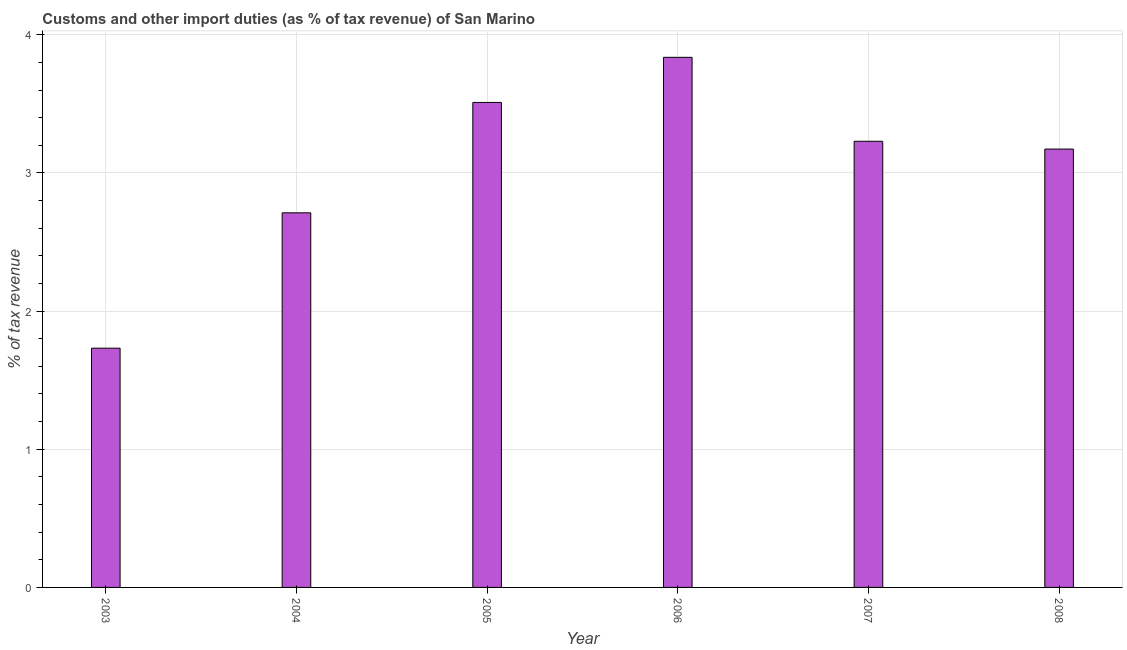Does the graph contain any zero values?
Provide a short and direct response. No. Does the graph contain grids?
Provide a short and direct response. Yes. What is the title of the graph?
Ensure brevity in your answer.  Customs and other import duties (as % of tax revenue) of San Marino. What is the label or title of the X-axis?
Provide a short and direct response. Year. What is the label or title of the Y-axis?
Give a very brief answer. % of tax revenue. What is the customs and other import duties in 2005?
Provide a succinct answer. 3.51. Across all years, what is the maximum customs and other import duties?
Your response must be concise. 3.84. Across all years, what is the minimum customs and other import duties?
Make the answer very short. 1.73. In which year was the customs and other import duties minimum?
Offer a terse response. 2003. What is the sum of the customs and other import duties?
Offer a very short reply. 18.19. What is the difference between the customs and other import duties in 2003 and 2008?
Provide a succinct answer. -1.44. What is the average customs and other import duties per year?
Offer a very short reply. 3.03. What is the median customs and other import duties?
Make the answer very short. 3.2. In how many years, is the customs and other import duties greater than 1 %?
Ensure brevity in your answer.  6. Do a majority of the years between 2003 and 2005 (inclusive) have customs and other import duties greater than 2.6 %?
Ensure brevity in your answer.  Yes. What is the ratio of the customs and other import duties in 2004 to that in 2006?
Provide a short and direct response. 0.71. What is the difference between the highest and the second highest customs and other import duties?
Provide a short and direct response. 0.33. Is the sum of the customs and other import duties in 2003 and 2005 greater than the maximum customs and other import duties across all years?
Your answer should be compact. Yes. What is the difference between the highest and the lowest customs and other import duties?
Provide a short and direct response. 2.11. In how many years, is the customs and other import duties greater than the average customs and other import duties taken over all years?
Your answer should be compact. 4. Are all the bars in the graph horizontal?
Offer a terse response. No. How many years are there in the graph?
Ensure brevity in your answer.  6. What is the difference between two consecutive major ticks on the Y-axis?
Provide a short and direct response. 1. Are the values on the major ticks of Y-axis written in scientific E-notation?
Your answer should be compact. No. What is the % of tax revenue in 2003?
Your answer should be very brief. 1.73. What is the % of tax revenue of 2004?
Offer a terse response. 2.71. What is the % of tax revenue of 2005?
Provide a succinct answer. 3.51. What is the % of tax revenue in 2006?
Your response must be concise. 3.84. What is the % of tax revenue in 2007?
Offer a terse response. 3.23. What is the % of tax revenue in 2008?
Offer a terse response. 3.17. What is the difference between the % of tax revenue in 2003 and 2004?
Provide a short and direct response. -0.98. What is the difference between the % of tax revenue in 2003 and 2005?
Provide a succinct answer. -1.78. What is the difference between the % of tax revenue in 2003 and 2006?
Offer a very short reply. -2.11. What is the difference between the % of tax revenue in 2003 and 2007?
Your answer should be very brief. -1.5. What is the difference between the % of tax revenue in 2003 and 2008?
Offer a terse response. -1.44. What is the difference between the % of tax revenue in 2004 and 2005?
Offer a terse response. -0.8. What is the difference between the % of tax revenue in 2004 and 2006?
Offer a very short reply. -1.13. What is the difference between the % of tax revenue in 2004 and 2007?
Keep it short and to the point. -0.52. What is the difference between the % of tax revenue in 2004 and 2008?
Keep it short and to the point. -0.46. What is the difference between the % of tax revenue in 2005 and 2006?
Give a very brief answer. -0.33. What is the difference between the % of tax revenue in 2005 and 2007?
Give a very brief answer. 0.28. What is the difference between the % of tax revenue in 2005 and 2008?
Provide a short and direct response. 0.34. What is the difference between the % of tax revenue in 2006 and 2007?
Offer a very short reply. 0.61. What is the difference between the % of tax revenue in 2006 and 2008?
Your answer should be very brief. 0.66. What is the difference between the % of tax revenue in 2007 and 2008?
Your answer should be very brief. 0.06. What is the ratio of the % of tax revenue in 2003 to that in 2004?
Your response must be concise. 0.64. What is the ratio of the % of tax revenue in 2003 to that in 2005?
Keep it short and to the point. 0.49. What is the ratio of the % of tax revenue in 2003 to that in 2006?
Ensure brevity in your answer.  0.45. What is the ratio of the % of tax revenue in 2003 to that in 2007?
Provide a succinct answer. 0.54. What is the ratio of the % of tax revenue in 2003 to that in 2008?
Your response must be concise. 0.55. What is the ratio of the % of tax revenue in 2004 to that in 2005?
Provide a short and direct response. 0.77. What is the ratio of the % of tax revenue in 2004 to that in 2006?
Make the answer very short. 0.71. What is the ratio of the % of tax revenue in 2004 to that in 2007?
Your answer should be compact. 0.84. What is the ratio of the % of tax revenue in 2004 to that in 2008?
Make the answer very short. 0.85. What is the ratio of the % of tax revenue in 2005 to that in 2006?
Your answer should be compact. 0.92. What is the ratio of the % of tax revenue in 2005 to that in 2007?
Offer a terse response. 1.09. What is the ratio of the % of tax revenue in 2005 to that in 2008?
Provide a short and direct response. 1.11. What is the ratio of the % of tax revenue in 2006 to that in 2007?
Your answer should be very brief. 1.19. What is the ratio of the % of tax revenue in 2006 to that in 2008?
Your answer should be very brief. 1.21. 